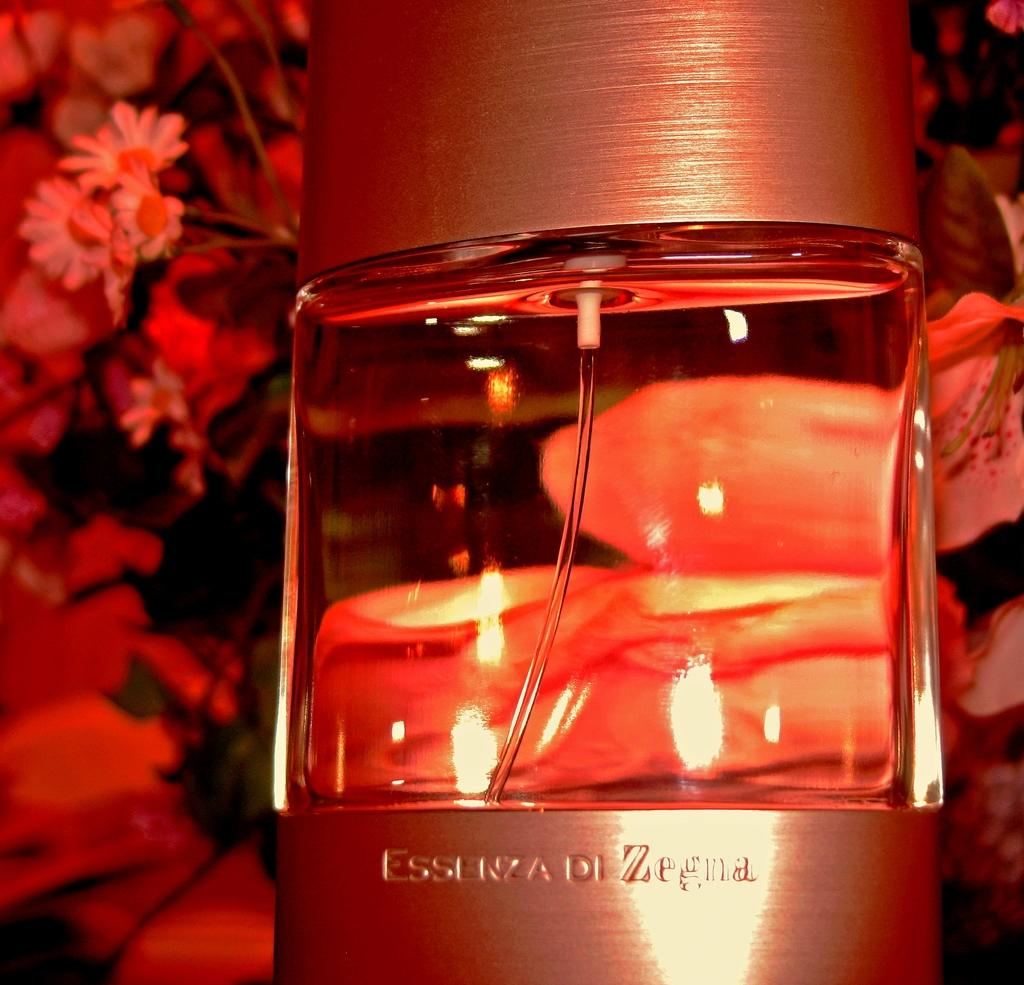<image>
Create a compact narrative representing the image presented. A bottle of perfume is labeled " Essenza di Zegna." 